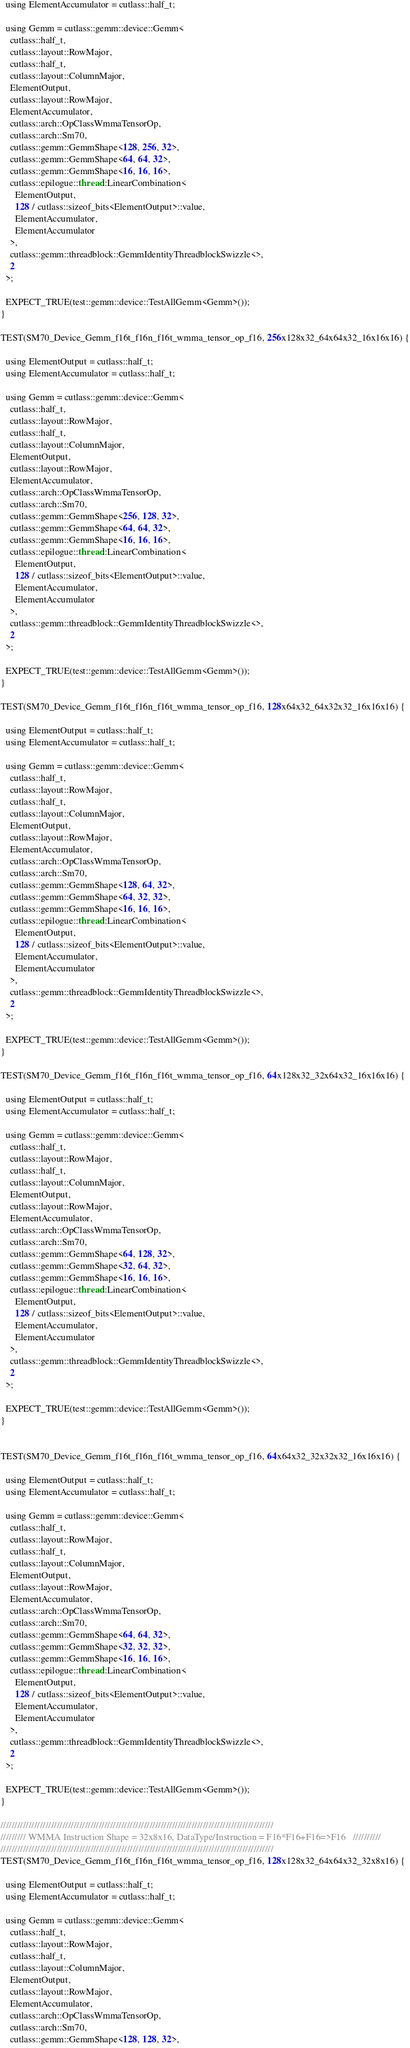Convert code to text. <code><loc_0><loc_0><loc_500><loc_500><_Cuda_>  using ElementAccumulator = cutlass::half_t;

  using Gemm = cutlass::gemm::device::Gemm<
    cutlass::half_t,
    cutlass::layout::RowMajor,
    cutlass::half_t,
    cutlass::layout::ColumnMajor,
    ElementOutput,
    cutlass::layout::RowMajor,
    ElementAccumulator,
    cutlass::arch::OpClassWmmaTensorOp,
    cutlass::arch::Sm70,
    cutlass::gemm::GemmShape<128, 256, 32>,
    cutlass::gemm::GemmShape<64, 64, 32>,
    cutlass::gemm::GemmShape<16, 16, 16>,
    cutlass::epilogue::thread::LinearCombination<
      ElementOutput,
      128 / cutlass::sizeof_bits<ElementOutput>::value,
      ElementAccumulator,
      ElementAccumulator
    >,
    cutlass::gemm::threadblock::GemmIdentityThreadblockSwizzle<>,
    2
  >;

  EXPECT_TRUE(test::gemm::device::TestAllGemm<Gemm>());
}

TEST(SM70_Device_Gemm_f16t_f16n_f16t_wmma_tensor_op_f16, 256x128x32_64x64x32_16x16x16) {

  using ElementOutput = cutlass::half_t;
  using ElementAccumulator = cutlass::half_t;

  using Gemm = cutlass::gemm::device::Gemm<
    cutlass::half_t,
    cutlass::layout::RowMajor,
    cutlass::half_t,
    cutlass::layout::ColumnMajor,
    ElementOutput,
    cutlass::layout::RowMajor,
    ElementAccumulator,
    cutlass::arch::OpClassWmmaTensorOp,
    cutlass::arch::Sm70,
    cutlass::gemm::GemmShape<256, 128, 32>,
    cutlass::gemm::GemmShape<64, 64, 32>,
    cutlass::gemm::GemmShape<16, 16, 16>,
    cutlass::epilogue::thread::LinearCombination<
      ElementOutput,
      128 / cutlass::sizeof_bits<ElementOutput>::value,
      ElementAccumulator,
      ElementAccumulator
    >,
    cutlass::gemm::threadblock::GemmIdentityThreadblockSwizzle<>,
    2
  >;

  EXPECT_TRUE(test::gemm::device::TestAllGemm<Gemm>());
}

TEST(SM70_Device_Gemm_f16t_f16n_f16t_wmma_tensor_op_f16, 128x64x32_64x32x32_16x16x16) {

  using ElementOutput = cutlass::half_t;
  using ElementAccumulator = cutlass::half_t;

  using Gemm = cutlass::gemm::device::Gemm<
    cutlass::half_t,
    cutlass::layout::RowMajor,
    cutlass::half_t,
    cutlass::layout::ColumnMajor,
    ElementOutput,
    cutlass::layout::RowMajor,
    ElementAccumulator,
    cutlass::arch::OpClassWmmaTensorOp,
    cutlass::arch::Sm70,
    cutlass::gemm::GemmShape<128, 64, 32>,
    cutlass::gemm::GemmShape<64, 32, 32>,
    cutlass::gemm::GemmShape<16, 16, 16>,
    cutlass::epilogue::thread::LinearCombination<
      ElementOutput,
      128 / cutlass::sizeof_bits<ElementOutput>::value,
      ElementAccumulator,
      ElementAccumulator
    >,
    cutlass::gemm::threadblock::GemmIdentityThreadblockSwizzle<>,
    2
  >;

  EXPECT_TRUE(test::gemm::device::TestAllGemm<Gemm>());
}

TEST(SM70_Device_Gemm_f16t_f16n_f16t_wmma_tensor_op_f16, 64x128x32_32x64x32_16x16x16) {

  using ElementOutput = cutlass::half_t;
  using ElementAccumulator = cutlass::half_t;

  using Gemm = cutlass::gemm::device::Gemm<
    cutlass::half_t,
    cutlass::layout::RowMajor,
    cutlass::half_t,
    cutlass::layout::ColumnMajor,
    ElementOutput,
    cutlass::layout::RowMajor,
    ElementAccumulator,
    cutlass::arch::OpClassWmmaTensorOp,
    cutlass::arch::Sm70,
    cutlass::gemm::GemmShape<64, 128, 32>,
    cutlass::gemm::GemmShape<32, 64, 32>,
    cutlass::gemm::GemmShape<16, 16, 16>,
    cutlass::epilogue::thread::LinearCombination<
      ElementOutput,
      128 / cutlass::sizeof_bits<ElementOutput>::value,
      ElementAccumulator,
      ElementAccumulator
    >,
    cutlass::gemm::threadblock::GemmIdentityThreadblockSwizzle<>,
    2
  >;

  EXPECT_TRUE(test::gemm::device::TestAllGemm<Gemm>());
}


TEST(SM70_Device_Gemm_f16t_f16n_f16t_wmma_tensor_op_f16, 64x64x32_32x32x32_16x16x16) {

  using ElementOutput = cutlass::half_t;
  using ElementAccumulator = cutlass::half_t;

  using Gemm = cutlass::gemm::device::Gemm<
    cutlass::half_t,
    cutlass::layout::RowMajor,
    cutlass::half_t,
    cutlass::layout::ColumnMajor,
    ElementOutput,
    cutlass::layout::RowMajor,
    ElementAccumulator,
    cutlass::arch::OpClassWmmaTensorOp,
    cutlass::arch::Sm70,
    cutlass::gemm::GemmShape<64, 64, 32>,
    cutlass::gemm::GemmShape<32, 32, 32>,
    cutlass::gemm::GemmShape<16, 16, 16>,
    cutlass::epilogue::thread::LinearCombination<
      ElementOutput,
      128 / cutlass::sizeof_bits<ElementOutput>::value,
      ElementAccumulator,
      ElementAccumulator
    >,
    cutlass::gemm::threadblock::GemmIdentityThreadblockSwizzle<>,
    2
  >;

  EXPECT_TRUE(test::gemm::device::TestAllGemm<Gemm>());
}

/////////////////////////////////////////////////////////////////////////////////////////////////
///////// WMMA Instruction Shape = 32x8x16, DataType/Instruction = F16*F16+F16=>F16   //////////
/////////////////////////////////////////////////////////////////////////////////////////////////    
TEST(SM70_Device_Gemm_f16t_f16n_f16t_wmma_tensor_op_f16, 128x128x32_64x64x32_32x8x16) {

  using ElementOutput = cutlass::half_t;
  using ElementAccumulator = cutlass::half_t;

  using Gemm = cutlass::gemm::device::Gemm<
    cutlass::half_t,
    cutlass::layout::RowMajor,
    cutlass::half_t,
    cutlass::layout::ColumnMajor,
    ElementOutput,
    cutlass::layout::RowMajor,
    ElementAccumulator,
    cutlass::arch::OpClassWmmaTensorOp,
    cutlass::arch::Sm70,
    cutlass::gemm::GemmShape<128, 128, 32>,</code> 